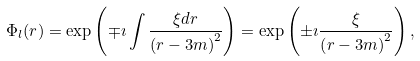<formula> <loc_0><loc_0><loc_500><loc_500>\Phi _ { l } ( r ) = \exp \left ( { \mp \imath \int \frac { \xi d r } { \left ( r - 3 m \right ) ^ { 2 } } } \right ) = \exp \left ( \pm \imath \frac { \xi } { \left ( r - 3 m \right ) ^ { 2 } } \right ) ,</formula> 